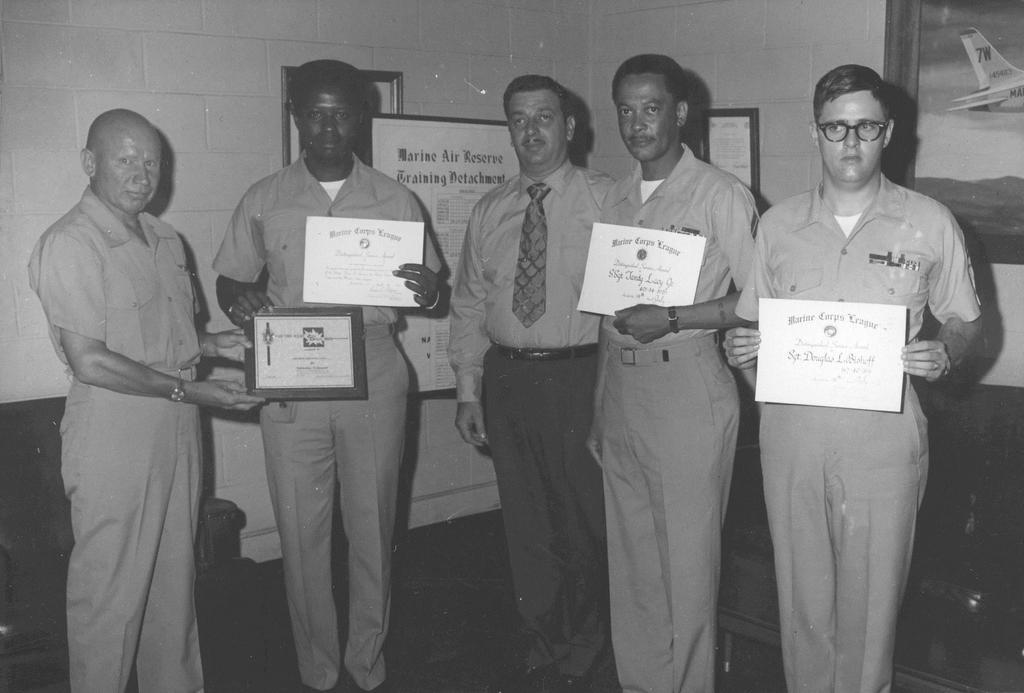How many people are in the image? There are people in the image, but the exact number is not specified. What are the people doing in the image? The people are standing in the image. What are the people holding in their hands? The people are holding awards in their hands. What can be seen on the wall in the image? There are frames visible on the wall. How many chairs are in the image? There is a chair on the right side of the image and a chair on the left side of the image. What type of stomach pain is the manager experiencing in the image? There is no mention of a manager or stomach pain in the image. The image features people holding awards, frames on the wall, and chairs. 